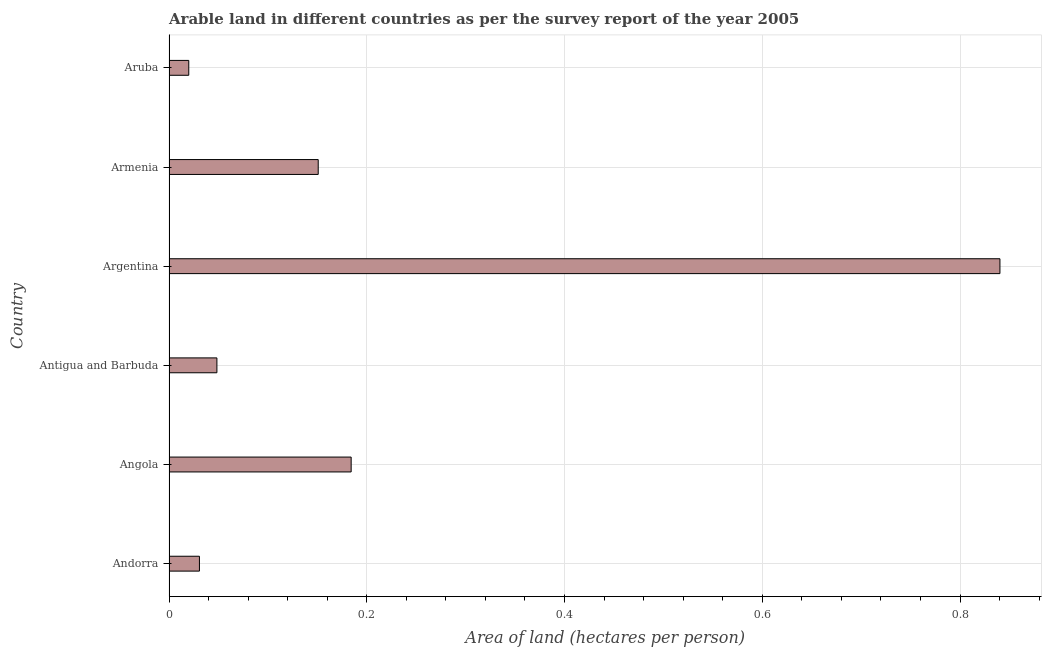Does the graph contain any zero values?
Offer a terse response. No. Does the graph contain grids?
Provide a succinct answer. Yes. What is the title of the graph?
Give a very brief answer. Arable land in different countries as per the survey report of the year 2005. What is the label or title of the X-axis?
Your answer should be compact. Area of land (hectares per person). What is the label or title of the Y-axis?
Keep it short and to the point. Country. What is the area of arable land in Angola?
Offer a very short reply. 0.18. Across all countries, what is the maximum area of arable land?
Provide a short and direct response. 0.84. Across all countries, what is the minimum area of arable land?
Keep it short and to the point. 0.02. In which country was the area of arable land maximum?
Keep it short and to the point. Argentina. In which country was the area of arable land minimum?
Provide a short and direct response. Aruba. What is the sum of the area of arable land?
Your answer should be compact. 1.27. What is the difference between the area of arable land in Andorra and Armenia?
Ensure brevity in your answer.  -0.12. What is the average area of arable land per country?
Ensure brevity in your answer.  0.21. What is the median area of arable land?
Ensure brevity in your answer.  0.1. What is the ratio of the area of arable land in Argentina to that in Armenia?
Make the answer very short. 5.57. Is the difference between the area of arable land in Andorra and Angola greater than the difference between any two countries?
Offer a very short reply. No. What is the difference between the highest and the second highest area of arable land?
Keep it short and to the point. 0.66. What is the difference between the highest and the lowest area of arable land?
Keep it short and to the point. 0.82. How many bars are there?
Your response must be concise. 6. What is the Area of land (hectares per person) of Andorra?
Make the answer very short. 0.03. What is the Area of land (hectares per person) of Angola?
Provide a succinct answer. 0.18. What is the Area of land (hectares per person) of Antigua and Barbuda?
Your response must be concise. 0.05. What is the Area of land (hectares per person) of Argentina?
Ensure brevity in your answer.  0.84. What is the Area of land (hectares per person) in Armenia?
Keep it short and to the point. 0.15. What is the Area of land (hectares per person) in Aruba?
Provide a short and direct response. 0.02. What is the difference between the Area of land (hectares per person) in Andorra and Angola?
Offer a terse response. -0.15. What is the difference between the Area of land (hectares per person) in Andorra and Antigua and Barbuda?
Offer a very short reply. -0.02. What is the difference between the Area of land (hectares per person) in Andorra and Argentina?
Ensure brevity in your answer.  -0.81. What is the difference between the Area of land (hectares per person) in Andorra and Armenia?
Make the answer very short. -0.12. What is the difference between the Area of land (hectares per person) in Andorra and Aruba?
Offer a very short reply. 0.01. What is the difference between the Area of land (hectares per person) in Angola and Antigua and Barbuda?
Give a very brief answer. 0.14. What is the difference between the Area of land (hectares per person) in Angola and Argentina?
Keep it short and to the point. -0.66. What is the difference between the Area of land (hectares per person) in Angola and Armenia?
Your answer should be compact. 0.03. What is the difference between the Area of land (hectares per person) in Angola and Aruba?
Your answer should be very brief. 0.16. What is the difference between the Area of land (hectares per person) in Antigua and Barbuda and Argentina?
Your answer should be very brief. -0.79. What is the difference between the Area of land (hectares per person) in Antigua and Barbuda and Armenia?
Offer a very short reply. -0.1. What is the difference between the Area of land (hectares per person) in Antigua and Barbuda and Aruba?
Provide a short and direct response. 0.03. What is the difference between the Area of land (hectares per person) in Argentina and Armenia?
Offer a very short reply. 0.69. What is the difference between the Area of land (hectares per person) in Argentina and Aruba?
Provide a succinct answer. 0.82. What is the difference between the Area of land (hectares per person) in Armenia and Aruba?
Keep it short and to the point. 0.13. What is the ratio of the Area of land (hectares per person) in Andorra to that in Angola?
Offer a terse response. 0.17. What is the ratio of the Area of land (hectares per person) in Andorra to that in Antigua and Barbuda?
Keep it short and to the point. 0.64. What is the ratio of the Area of land (hectares per person) in Andorra to that in Argentina?
Your answer should be compact. 0.04. What is the ratio of the Area of land (hectares per person) in Andorra to that in Armenia?
Keep it short and to the point. 0.2. What is the ratio of the Area of land (hectares per person) in Andorra to that in Aruba?
Your response must be concise. 1.54. What is the ratio of the Area of land (hectares per person) in Angola to that in Antigua and Barbuda?
Provide a short and direct response. 3.8. What is the ratio of the Area of land (hectares per person) in Angola to that in Argentina?
Provide a succinct answer. 0.22. What is the ratio of the Area of land (hectares per person) in Angola to that in Armenia?
Your answer should be compact. 1.22. What is the ratio of the Area of land (hectares per person) in Angola to that in Aruba?
Ensure brevity in your answer.  9.21. What is the ratio of the Area of land (hectares per person) in Antigua and Barbuda to that in Argentina?
Provide a short and direct response. 0.06. What is the ratio of the Area of land (hectares per person) in Antigua and Barbuda to that in Armenia?
Make the answer very short. 0.32. What is the ratio of the Area of land (hectares per person) in Antigua and Barbuda to that in Aruba?
Ensure brevity in your answer.  2.42. What is the ratio of the Area of land (hectares per person) in Argentina to that in Armenia?
Your response must be concise. 5.57. What is the ratio of the Area of land (hectares per person) in Argentina to that in Aruba?
Keep it short and to the point. 42.03. What is the ratio of the Area of land (hectares per person) in Armenia to that in Aruba?
Ensure brevity in your answer.  7.55. 